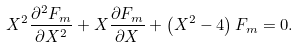<formula> <loc_0><loc_0><loc_500><loc_500>X ^ { 2 } \frac { \partial ^ { 2 } F _ { m } } { \partial X ^ { 2 } } + X \frac { \partial F _ { m } } { \partial X } + \left ( X ^ { 2 } - 4 \right ) F _ { m } = 0 .</formula> 